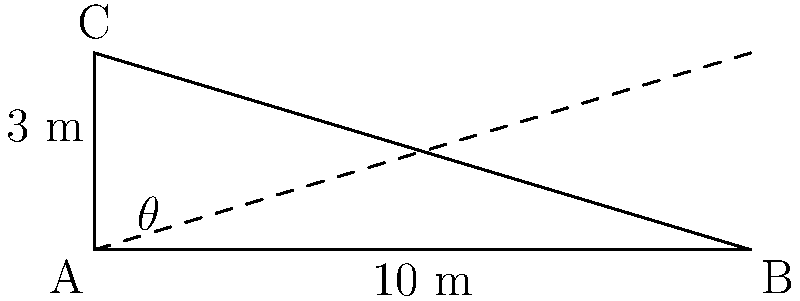As a small business owner, you need to design a ramp for safely loading goods onto trucks. The height difference between the ground and the truck bed is 3 meters, and you have 10 meters of horizontal space available. What is the angle of inclination ($\theta$) of the ramp in degrees? To find the angle of inclination, we can use the arctangent function. Here's how:

1. Identify the right triangle formed by the ramp:
   - The opposite side (height difference) is 3 meters
   - The adjacent side (horizontal distance) is 10 meters

2. Use the tangent function:
   $\tan(\theta) = \frac{\text{opposite}}{\text{adjacent}} = \frac{3}{10}$

3. To find $\theta$, we need to use the inverse tangent (arctangent) function:
   $\theta = \arctan(\frac{3}{10})$

4. Calculate the result:
   $\theta = \arctan(0.3) \approx 16.70^\circ$

5. Round to two decimal places:
   $\theta \approx 16.70^\circ$
Answer: $16.70^\circ$ 